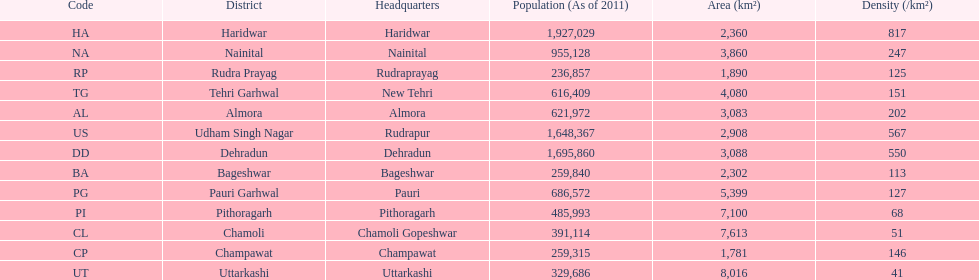Which has a larger population, dehradun or nainital? Dehradun. 